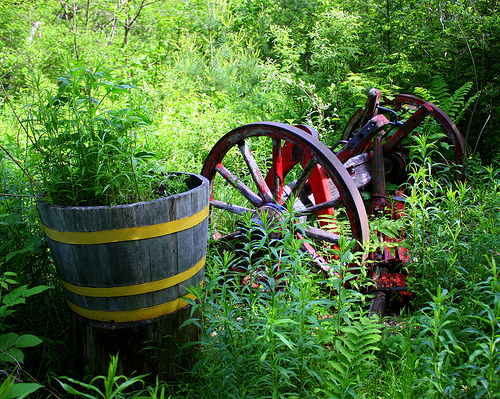<image>
Is the weed in the stump? Yes. The weed is contained within or inside the stump, showing a containment relationship. Is there a flower pot to the left of the wheel? Yes. From this viewpoint, the flower pot is positioned to the left side relative to the wheel. 